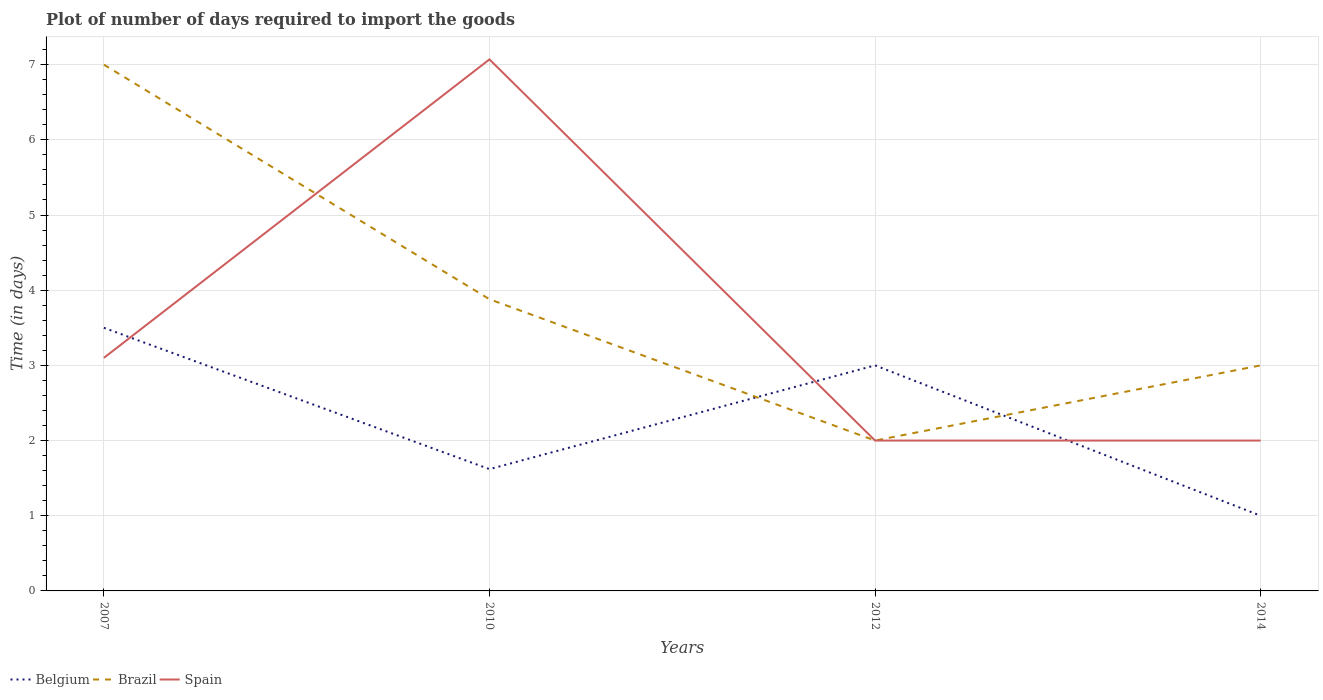Across all years, what is the maximum time required to import goods in Spain?
Offer a terse response. 2. In which year was the time required to import goods in Brazil maximum?
Give a very brief answer. 2012. What is the total time required to import goods in Spain in the graph?
Your answer should be very brief. 5.07. What is the difference between the highest and the second highest time required to import goods in Spain?
Make the answer very short. 5.07. What is the difference between the highest and the lowest time required to import goods in Spain?
Your answer should be very brief. 1. How many lines are there?
Make the answer very short. 3. What is the difference between two consecutive major ticks on the Y-axis?
Give a very brief answer. 1. Are the values on the major ticks of Y-axis written in scientific E-notation?
Your answer should be very brief. No. Does the graph contain any zero values?
Provide a succinct answer. No. Does the graph contain grids?
Make the answer very short. Yes. Where does the legend appear in the graph?
Provide a short and direct response. Bottom left. How are the legend labels stacked?
Ensure brevity in your answer.  Horizontal. What is the title of the graph?
Offer a very short reply. Plot of number of days required to import the goods. Does "Latin America(developing only)" appear as one of the legend labels in the graph?
Provide a succinct answer. No. What is the label or title of the X-axis?
Your answer should be compact. Years. What is the label or title of the Y-axis?
Provide a short and direct response. Time (in days). What is the Time (in days) of Belgium in 2007?
Your answer should be very brief. 3.5. What is the Time (in days) in Brazil in 2007?
Make the answer very short. 7. What is the Time (in days) in Spain in 2007?
Make the answer very short. 3.1. What is the Time (in days) in Belgium in 2010?
Your response must be concise. 1.62. What is the Time (in days) of Brazil in 2010?
Provide a succinct answer. 3.88. What is the Time (in days) in Spain in 2010?
Provide a short and direct response. 7.07. What is the Time (in days) in Spain in 2012?
Your answer should be very brief. 2. What is the Time (in days) in Belgium in 2014?
Offer a terse response. 1. What is the Time (in days) of Brazil in 2014?
Offer a terse response. 3. Across all years, what is the maximum Time (in days) of Belgium?
Keep it short and to the point. 3.5. Across all years, what is the maximum Time (in days) in Brazil?
Offer a very short reply. 7. Across all years, what is the maximum Time (in days) in Spain?
Provide a short and direct response. 7.07. Across all years, what is the minimum Time (in days) of Brazil?
Give a very brief answer. 2. What is the total Time (in days) of Belgium in the graph?
Give a very brief answer. 9.12. What is the total Time (in days) in Brazil in the graph?
Provide a short and direct response. 15.88. What is the total Time (in days) of Spain in the graph?
Your response must be concise. 14.17. What is the difference between the Time (in days) of Belgium in 2007 and that in 2010?
Your answer should be very brief. 1.88. What is the difference between the Time (in days) of Brazil in 2007 and that in 2010?
Provide a short and direct response. 3.12. What is the difference between the Time (in days) in Spain in 2007 and that in 2010?
Offer a very short reply. -3.97. What is the difference between the Time (in days) of Belgium in 2007 and that in 2012?
Offer a terse response. 0.5. What is the difference between the Time (in days) in Spain in 2007 and that in 2012?
Give a very brief answer. 1.1. What is the difference between the Time (in days) of Spain in 2007 and that in 2014?
Your answer should be very brief. 1.1. What is the difference between the Time (in days) of Belgium in 2010 and that in 2012?
Provide a short and direct response. -1.38. What is the difference between the Time (in days) in Brazil in 2010 and that in 2012?
Ensure brevity in your answer.  1.88. What is the difference between the Time (in days) in Spain in 2010 and that in 2012?
Your response must be concise. 5.07. What is the difference between the Time (in days) in Belgium in 2010 and that in 2014?
Offer a very short reply. 0.62. What is the difference between the Time (in days) of Brazil in 2010 and that in 2014?
Offer a terse response. 0.88. What is the difference between the Time (in days) in Spain in 2010 and that in 2014?
Provide a short and direct response. 5.07. What is the difference between the Time (in days) in Belgium in 2012 and that in 2014?
Offer a terse response. 2. What is the difference between the Time (in days) of Spain in 2012 and that in 2014?
Give a very brief answer. 0. What is the difference between the Time (in days) of Belgium in 2007 and the Time (in days) of Brazil in 2010?
Offer a very short reply. -0.38. What is the difference between the Time (in days) in Belgium in 2007 and the Time (in days) in Spain in 2010?
Ensure brevity in your answer.  -3.57. What is the difference between the Time (in days) of Brazil in 2007 and the Time (in days) of Spain in 2010?
Offer a very short reply. -0.07. What is the difference between the Time (in days) in Belgium in 2007 and the Time (in days) in Brazil in 2012?
Your answer should be very brief. 1.5. What is the difference between the Time (in days) of Belgium in 2007 and the Time (in days) of Spain in 2012?
Your answer should be compact. 1.5. What is the difference between the Time (in days) in Belgium in 2007 and the Time (in days) in Brazil in 2014?
Ensure brevity in your answer.  0.5. What is the difference between the Time (in days) of Belgium in 2007 and the Time (in days) of Spain in 2014?
Make the answer very short. 1.5. What is the difference between the Time (in days) in Belgium in 2010 and the Time (in days) in Brazil in 2012?
Offer a terse response. -0.38. What is the difference between the Time (in days) of Belgium in 2010 and the Time (in days) of Spain in 2012?
Your answer should be compact. -0.38. What is the difference between the Time (in days) in Brazil in 2010 and the Time (in days) in Spain in 2012?
Your answer should be very brief. 1.88. What is the difference between the Time (in days) in Belgium in 2010 and the Time (in days) in Brazil in 2014?
Keep it short and to the point. -1.38. What is the difference between the Time (in days) in Belgium in 2010 and the Time (in days) in Spain in 2014?
Make the answer very short. -0.38. What is the difference between the Time (in days) in Brazil in 2010 and the Time (in days) in Spain in 2014?
Make the answer very short. 1.88. What is the difference between the Time (in days) in Belgium in 2012 and the Time (in days) in Brazil in 2014?
Provide a short and direct response. 0. What is the average Time (in days) in Belgium per year?
Provide a succinct answer. 2.28. What is the average Time (in days) in Brazil per year?
Provide a short and direct response. 3.97. What is the average Time (in days) in Spain per year?
Give a very brief answer. 3.54. In the year 2007, what is the difference between the Time (in days) in Belgium and Time (in days) in Brazil?
Your answer should be compact. -3.5. In the year 2007, what is the difference between the Time (in days) in Belgium and Time (in days) in Spain?
Give a very brief answer. 0.4. In the year 2007, what is the difference between the Time (in days) in Brazil and Time (in days) in Spain?
Provide a succinct answer. 3.9. In the year 2010, what is the difference between the Time (in days) of Belgium and Time (in days) of Brazil?
Provide a short and direct response. -2.26. In the year 2010, what is the difference between the Time (in days) of Belgium and Time (in days) of Spain?
Keep it short and to the point. -5.45. In the year 2010, what is the difference between the Time (in days) in Brazil and Time (in days) in Spain?
Your answer should be compact. -3.19. In the year 2014, what is the difference between the Time (in days) in Belgium and Time (in days) in Brazil?
Keep it short and to the point. -2. In the year 2014, what is the difference between the Time (in days) of Belgium and Time (in days) of Spain?
Your answer should be very brief. -1. What is the ratio of the Time (in days) of Belgium in 2007 to that in 2010?
Provide a short and direct response. 2.16. What is the ratio of the Time (in days) of Brazil in 2007 to that in 2010?
Offer a terse response. 1.8. What is the ratio of the Time (in days) in Spain in 2007 to that in 2010?
Your answer should be compact. 0.44. What is the ratio of the Time (in days) in Brazil in 2007 to that in 2012?
Keep it short and to the point. 3.5. What is the ratio of the Time (in days) of Spain in 2007 to that in 2012?
Your answer should be very brief. 1.55. What is the ratio of the Time (in days) of Brazil in 2007 to that in 2014?
Offer a very short reply. 2.33. What is the ratio of the Time (in days) in Spain in 2007 to that in 2014?
Offer a very short reply. 1.55. What is the ratio of the Time (in days) in Belgium in 2010 to that in 2012?
Ensure brevity in your answer.  0.54. What is the ratio of the Time (in days) in Brazil in 2010 to that in 2012?
Your response must be concise. 1.94. What is the ratio of the Time (in days) in Spain in 2010 to that in 2012?
Make the answer very short. 3.54. What is the ratio of the Time (in days) in Belgium in 2010 to that in 2014?
Give a very brief answer. 1.62. What is the ratio of the Time (in days) in Brazil in 2010 to that in 2014?
Your response must be concise. 1.29. What is the ratio of the Time (in days) in Spain in 2010 to that in 2014?
Keep it short and to the point. 3.54. What is the ratio of the Time (in days) in Belgium in 2012 to that in 2014?
Provide a succinct answer. 3. What is the difference between the highest and the second highest Time (in days) in Brazil?
Ensure brevity in your answer.  3.12. What is the difference between the highest and the second highest Time (in days) of Spain?
Ensure brevity in your answer.  3.97. What is the difference between the highest and the lowest Time (in days) in Belgium?
Offer a very short reply. 2.5. What is the difference between the highest and the lowest Time (in days) of Brazil?
Your answer should be very brief. 5. What is the difference between the highest and the lowest Time (in days) of Spain?
Make the answer very short. 5.07. 